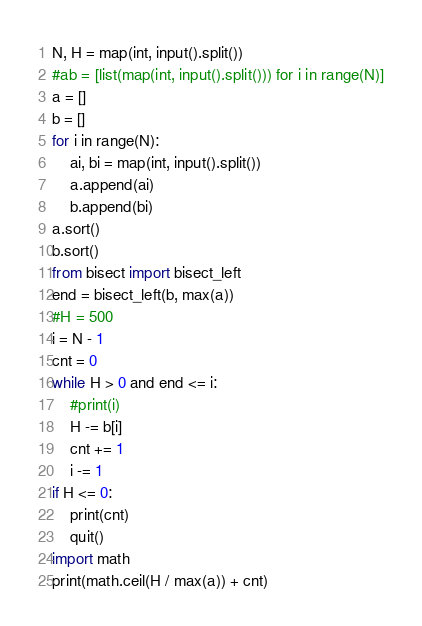Convert code to text. <code><loc_0><loc_0><loc_500><loc_500><_Python_>N, H = map(int, input().split())
#ab = [list(map(int, input().split())) for i in range(N)]
a = []
b = []
for i in range(N):
    ai, bi = map(int, input().split())
    a.append(ai)
    b.append(bi)
a.sort()
b.sort()
from bisect import bisect_left
end = bisect_left(b, max(a))
#H = 500
i = N - 1
cnt = 0
while H > 0 and end <= i:
    #print(i)
    H -= b[i]
    cnt += 1
    i -= 1
if H <= 0:
    print(cnt)
    quit()
import math
print(math.ceil(H / max(a)) + cnt)</code> 